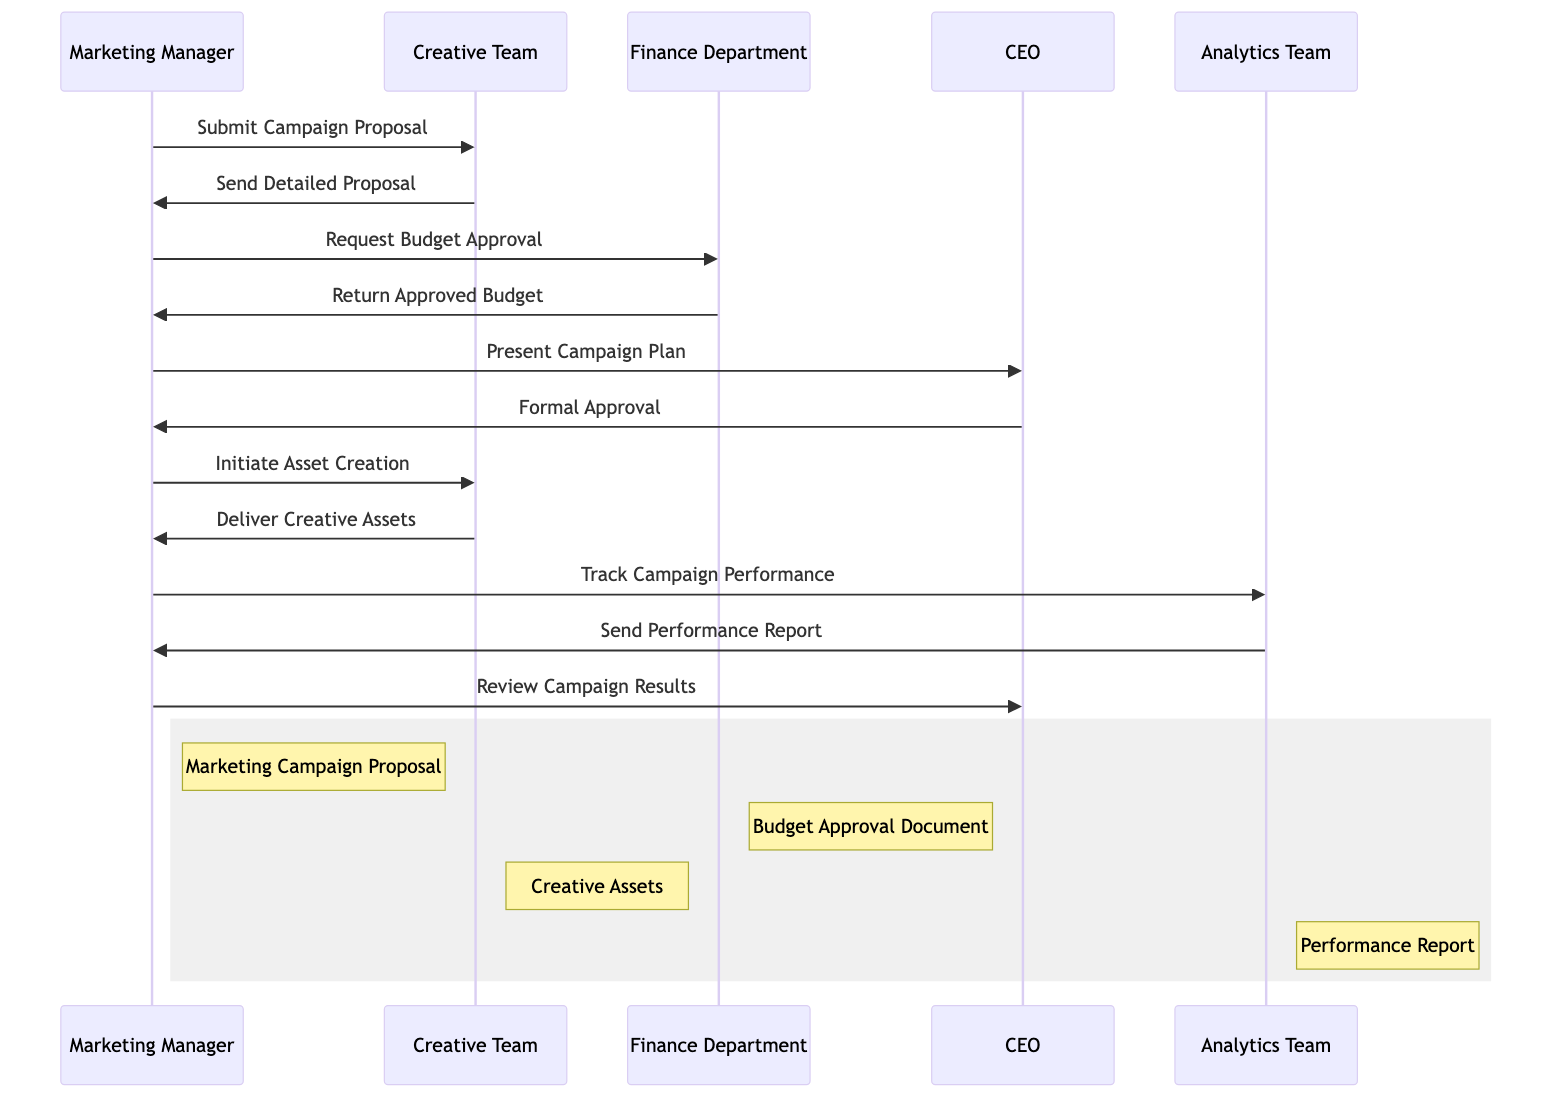What's the first action taken in the sequence? The first action taken is "Submit Campaign Proposal," initiated by the Marketing Manager to the Creative Team.
Answer: Submit Campaign Proposal How many departments are involved in the marketing campaign process? The diagram includes four departments: Marketing Manager, Creative Team, Finance Department, and Analytics Team. CEO is also included.
Answer: Five What document does the Finance Department return? The document returned by the Finance Department is the "Approved Budget" upon request from the Marketing Manager.
Answer: Approved Budget Which actor presents the campaign plan? The Marketing Manager is responsible for presenting the campaign plan to the CEO.
Answer: Marketing Manager What follows after the CEO gives formal approval? After the CEO gives formal approval, the Marketing Manager initiates asset creation with the Creative Team.
Answer: Initiate Asset Creation How many performance reports are indicated in the diagram? There is one performance report mentioned in the diagram that the Analytics Team sends to the Marketing Manager.
Answer: One Which team delivers the creative assets? The Creative Team is responsible for delivering the creative assets back to the Marketing Manager after the asset creation is initiated.
Answer: Creative Team What is the last action taken in the sequence? The last action taken is "Review Campaign Results," where the Marketing Manager reviews the results with the CEO.
Answer: Review Campaign Results In the sequence, which department does the Analytics Team report to? The Analytics Team sends the performance report to the Marketing Manager, hence they report to them.
Answer: Marketing Manager What type of asset is involved in the campaign execution? The asset involved is "Creative Assets," which are created and delivered by the Creative Team.
Answer: Creative Assets 